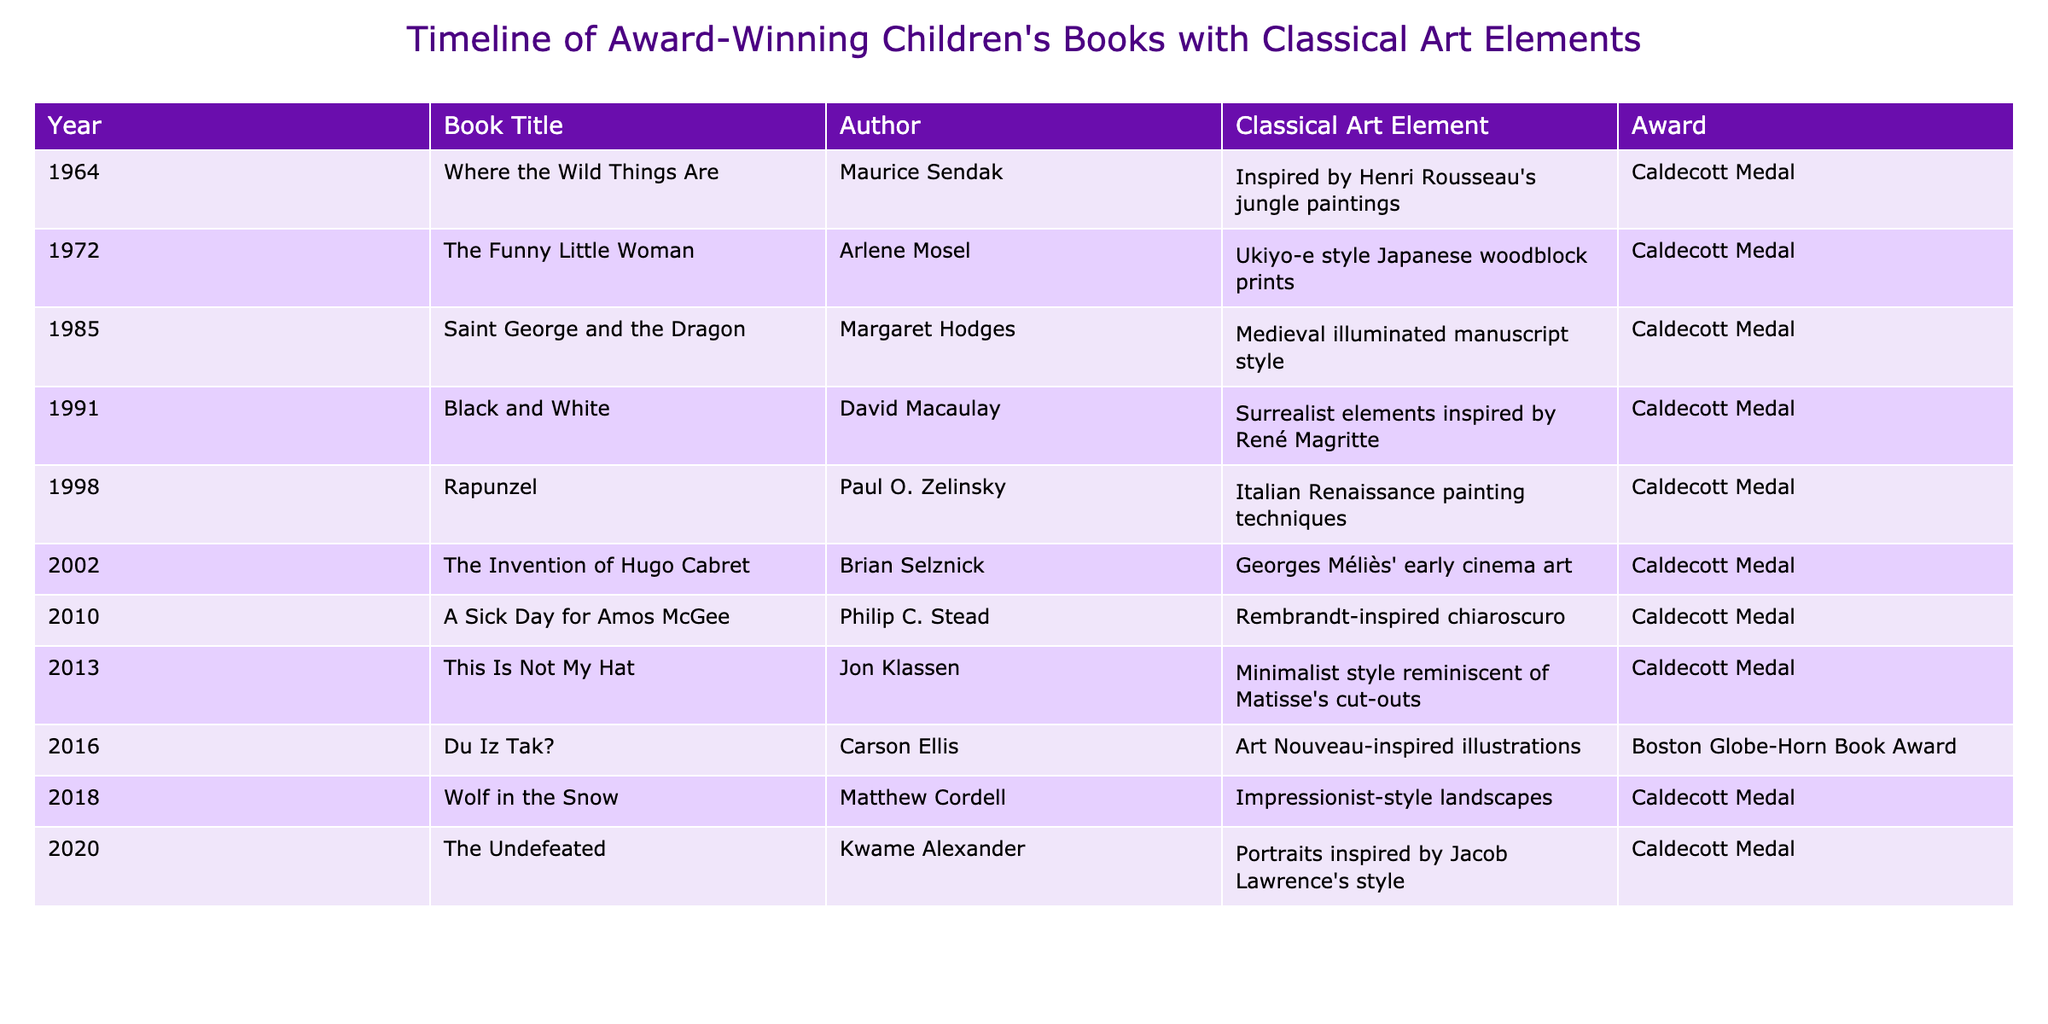What year was "Where the Wild Things Are" published? The table indicates that "Where the Wild Things Are" was published in the year 1964.
Answer: 1964 Who is the author of "The Invention of Hugo Cabret"? According to the table, the author of "The Invention of Hugo Cabret" is Brian Selznick.
Answer: Brian Selznick How many books in the table won the Caldecott Medal? By counting the entries where the Award is "Caldecott Medal", we find there are 9 books that won this award.
Answer: 9 Is "Du Iz Tak?" associated with any awards? The table shows that "Du Iz Tak?" won the Boston Globe-Horn Book Award, indicating that yes, it is associated with an award.
Answer: Yes Which classical art element is associated with "Rapunzel"? The table states that "Rapunzel" features Italian Renaissance painting techniques as its classical art element.
Answer: Italian Renaissance painting techniques What is the difference in publication years between "Saint George and the Dragon" and "A Sick Day for Amos McGee"? "Saint George and the Dragon" was published in 1985 and "A Sick Day for Amos McGee" was published in 2010. The difference is 2010 - 1985 = 25 years.
Answer: 25 years Which author has the most titles listed in the table? Analyzing the authors, Maurice Sendak, Arlene Mosel, and others have one title each, and David Macaulay also has one. However, no author appears more than once, so they all have an equal count of one book.
Answer: None, all are equal with one title each What styles are incorporated in the books published after 2010? The styles in the books after 2010 ("A Sick Day for Amos McGee", "This Is Not My Hat", "Du Iz Tak?", "Wolf in the Snow", "The Undefeated") include Rembrandt-inspired chiaroscuro, minimalist style reminiscent of Matisse's cut-outs, Art Nouveau-inspired illustrations, Impressionist-style landscapes, and portraits inspired by Jacob Lawrence's style.
Answer: Multiple styles including Rembrandt, Matisse, Art Nouveau, Impressionism, and Jacob Lawrence Which book has the earliest publication date featuring a classical art element? The earliest book in the table is "Where the Wild Things Are," published in 1964, featuring classical art inspired by Henri Rousseau's jungle paintings.
Answer: Where the Wild Things Are 